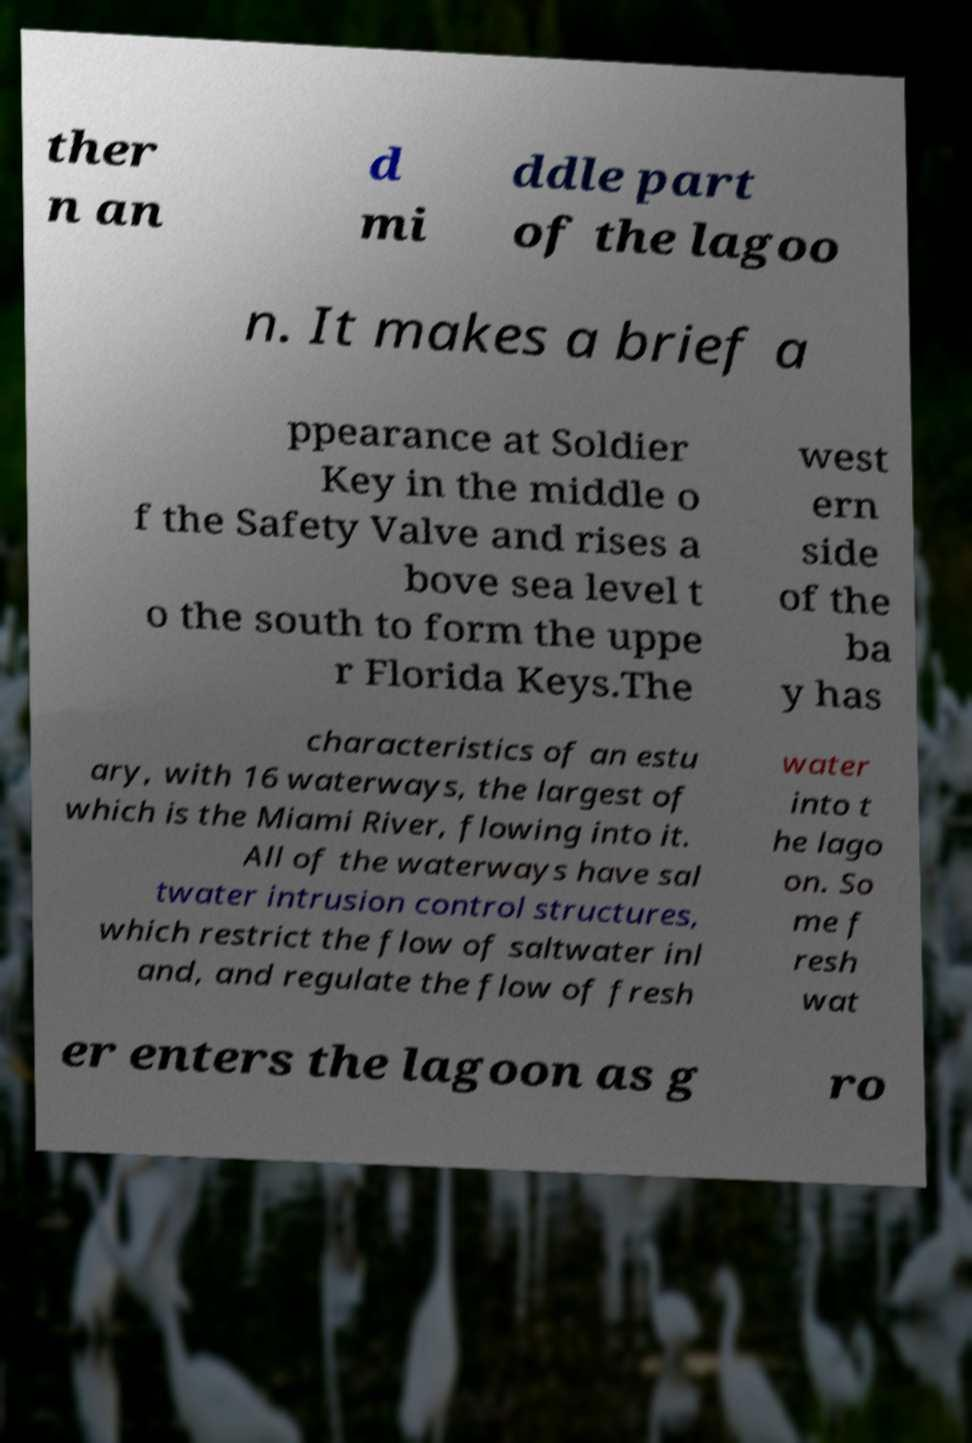Please read and relay the text visible in this image. What does it say? ther n an d mi ddle part of the lagoo n. It makes a brief a ppearance at Soldier Key in the middle o f the Safety Valve and rises a bove sea level t o the south to form the uppe r Florida Keys.The west ern side of the ba y has characteristics of an estu ary, with 16 waterways, the largest of which is the Miami River, flowing into it. All of the waterways have sal twater intrusion control structures, which restrict the flow of saltwater inl and, and regulate the flow of fresh water into t he lago on. So me f resh wat er enters the lagoon as g ro 